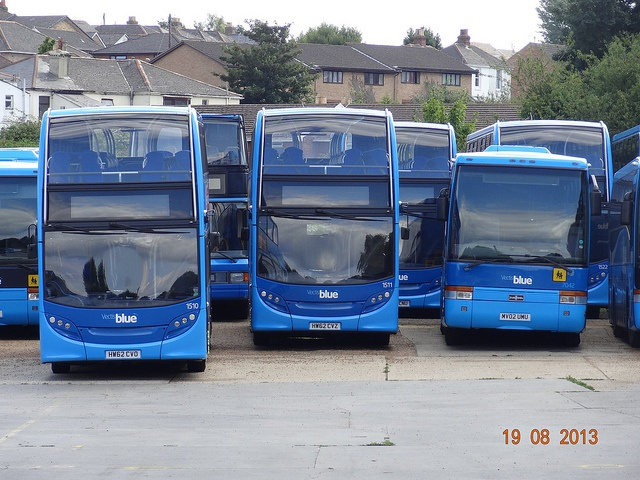Describe the objects in this image and their specific colors. I can see bus in white, gray, blue, navy, and darkgray tones, bus in white, gray, blue, and black tones, bus in white, blue, gray, navy, and black tones, bus in white, navy, black, blue, and gray tones, and bus in white, black, navy, and gray tones in this image. 